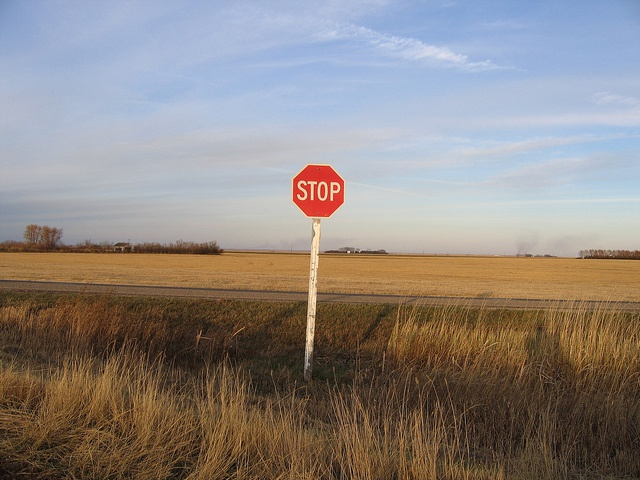Describe the objects in this image and their specific colors. I can see a stop sign in gray, red, tan, and salmon tones in this image. 